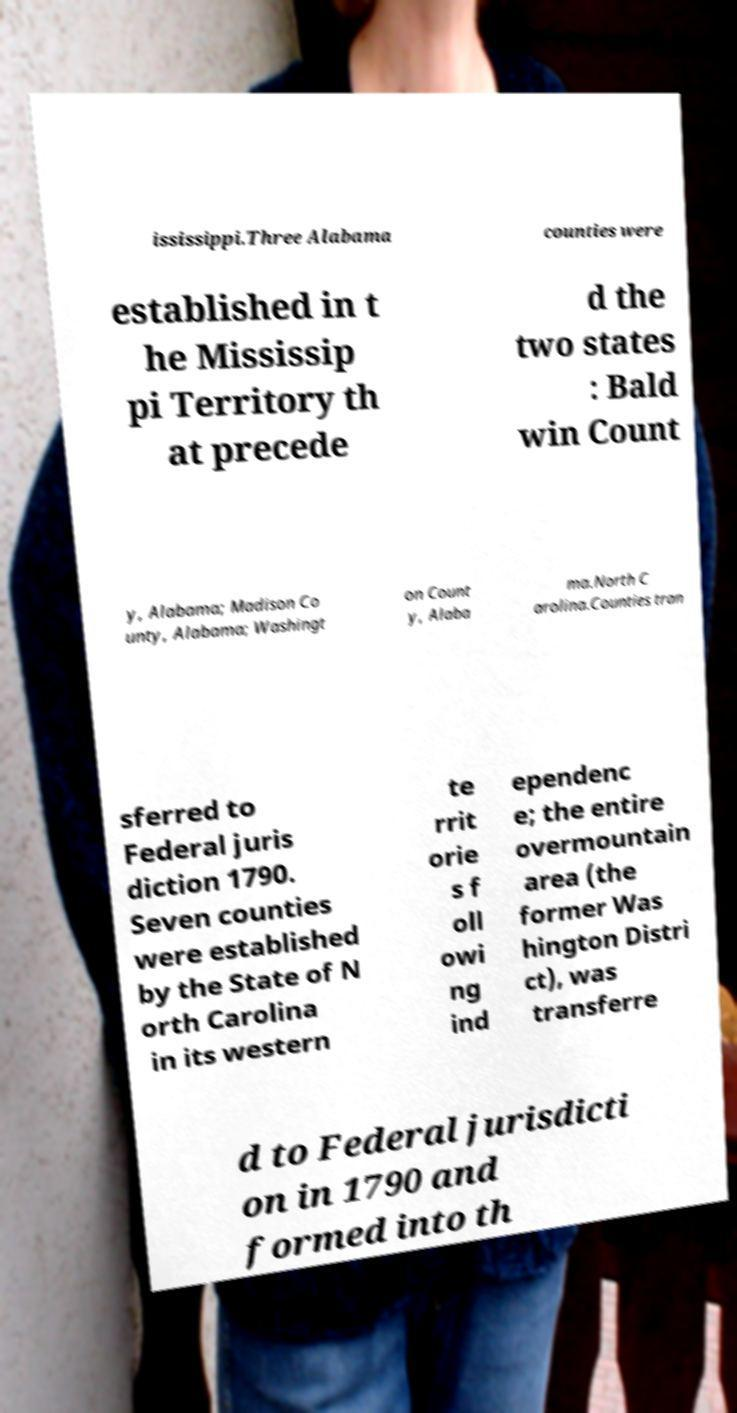What messages or text are displayed in this image? I need them in a readable, typed format. ississippi.Three Alabama counties were established in t he Mississip pi Territory th at precede d the two states : Bald win Count y, Alabama; Madison Co unty, Alabama; Washingt on Count y, Alaba ma.North C arolina.Counties tran sferred to Federal juris diction 1790. Seven counties were established by the State of N orth Carolina in its western te rrit orie s f oll owi ng ind ependenc e; the entire overmountain area (the former Was hington Distri ct), was transferre d to Federal jurisdicti on in 1790 and formed into th 